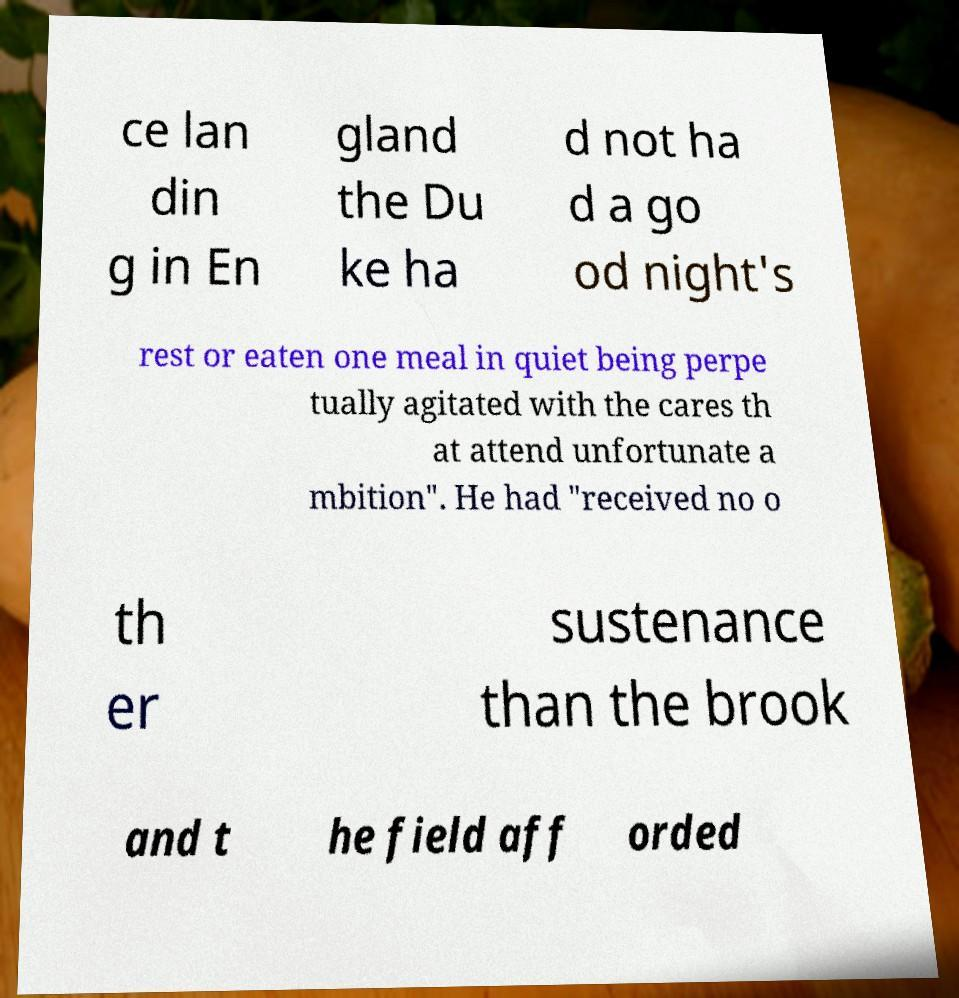Can you read and provide the text displayed in the image?This photo seems to have some interesting text. Can you extract and type it out for me? ce lan din g in En gland the Du ke ha d not ha d a go od night's rest or eaten one meal in quiet being perpe tually agitated with the cares th at attend unfortunate a mbition". He had "received no o th er sustenance than the brook and t he field aff orded 